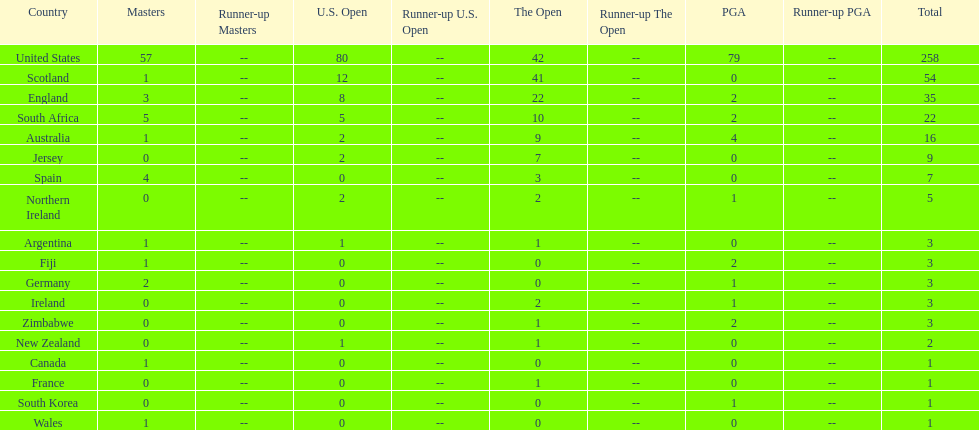Write the full table. {'header': ['Country', 'Masters', 'Runner-up Masters', 'U.S. Open', 'Runner-up U.S. Open', 'The Open', 'Runner-up The Open', 'PGA', 'Runner-up PGA', 'Total'], 'rows': [['United States', '57', '--', '80', '--', '42', '--', '79', '--', '258'], ['Scotland', '1', '--', '12', '--', '41', '--', '0', '--', '54'], ['England', '3', '--', '8', '--', '22', '--', '2', '--', '35'], ['South Africa', '5', '--', '5', '--', '10', '--', '2', '--', '22'], ['Australia', '1', '--', '2', '--', '9', '--', '4', '--', '16'], ['Jersey', '0', '--', '2', '--', '7', '--', '0', '--', '9'], ['Spain', '4', '--', '0', '--', '3', '--', '0', '--', '7'], ['Northern Ireland', '0', '--', '2', '--', '2', '--', '1', '--', '5'], ['Argentina', '1', '--', '1', '--', '1', '--', '0', '--', '3'], ['Fiji', '1', '--', '0', '--', '0', '--', '2', '--', '3'], ['Germany', '2', '--', '0', '--', '0', '--', '1', '--', '3'], ['Ireland', '0', '--', '0', '--', '2', '--', '1', '--', '3'], ['Zimbabwe', '0', '--', '0', '--', '1', '--', '2', '--', '3'], ['New Zealand', '0', '--', '1', '--', '1', '--', '0', '--', '2'], ['Canada', '1', '--', '0', '--', '0', '--', '0', '--', '1'], ['France', '0', '--', '0', '--', '1', '--', '0', '--', '1'], ['South Korea', '0', '--', '0', '--', '0', '--', '1', '--', '1'], ['Wales', '1', '--', '0', '--', '0', '--', '0', '--', '1']]} What is the combined number of masters champions hailing from england and wales? 4. 